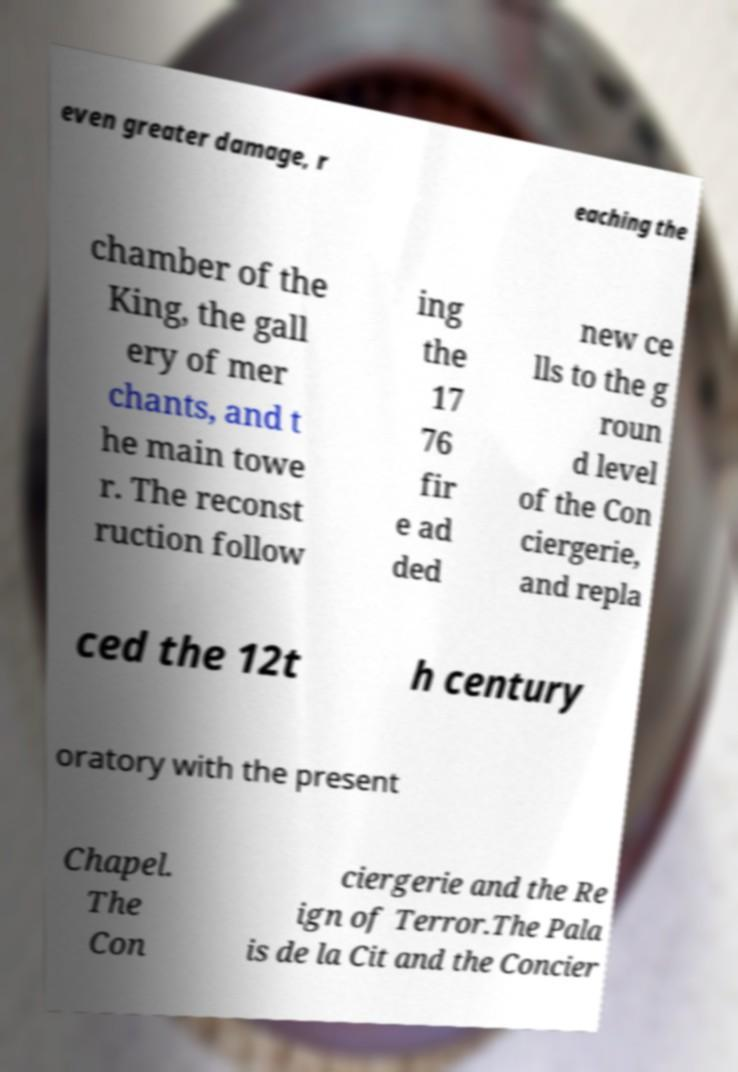Can you read and provide the text displayed in the image?This photo seems to have some interesting text. Can you extract and type it out for me? even greater damage, r eaching the chamber of the King, the gall ery of mer chants, and t he main towe r. The reconst ruction follow ing the 17 76 fir e ad ded new ce lls to the g roun d level of the Con ciergerie, and repla ced the 12t h century oratory with the present Chapel. The Con ciergerie and the Re ign of Terror.The Pala is de la Cit and the Concier 